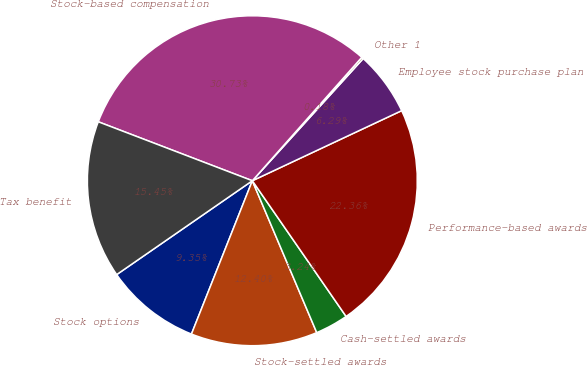<chart> <loc_0><loc_0><loc_500><loc_500><pie_chart><fcel>Stock options<fcel>Stock-settled awards<fcel>Cash-settled awards<fcel>Performance-based awards<fcel>Employee stock purchase plan<fcel>Other 1<fcel>Stock-based compensation<fcel>Tax benefit<nl><fcel>9.35%<fcel>12.4%<fcel>3.24%<fcel>22.36%<fcel>6.29%<fcel>0.18%<fcel>30.73%<fcel>15.45%<nl></chart> 